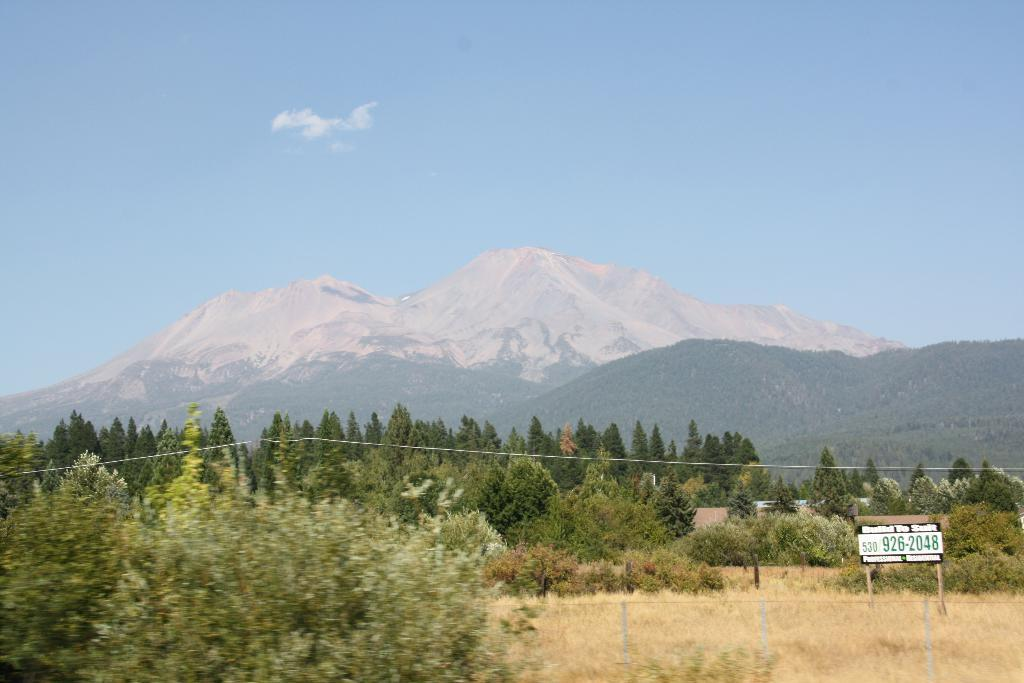What type of natural environment is depicted in the image? There are many trees and mountains in the image, suggesting a natural environment. What man-made object can be seen in the image? There is an advertising board in the image. What is visible in the sky in the image? The sky is visible in the image. What type of barrier is present in the image? There is a fencing in the image. How does the beginner handle the earthquake in the image? There is no earthquake or beginner present in the image; it features trees, mountains, an advertising board, the sky, and a fencing. 